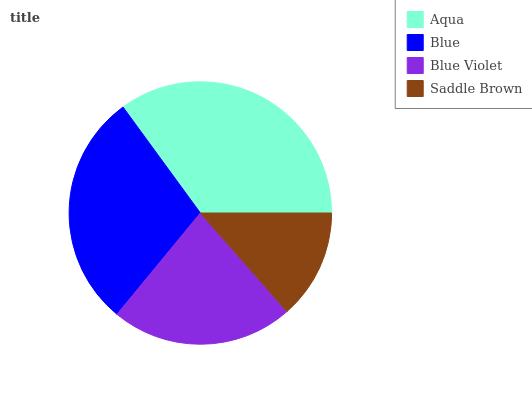Is Saddle Brown the minimum?
Answer yes or no. Yes. Is Aqua the maximum?
Answer yes or no. Yes. Is Blue the minimum?
Answer yes or no. No. Is Blue the maximum?
Answer yes or no. No. Is Aqua greater than Blue?
Answer yes or no. Yes. Is Blue less than Aqua?
Answer yes or no. Yes. Is Blue greater than Aqua?
Answer yes or no. No. Is Aqua less than Blue?
Answer yes or no. No. Is Blue the high median?
Answer yes or no. Yes. Is Blue Violet the low median?
Answer yes or no. Yes. Is Saddle Brown the high median?
Answer yes or no. No. Is Aqua the low median?
Answer yes or no. No. 